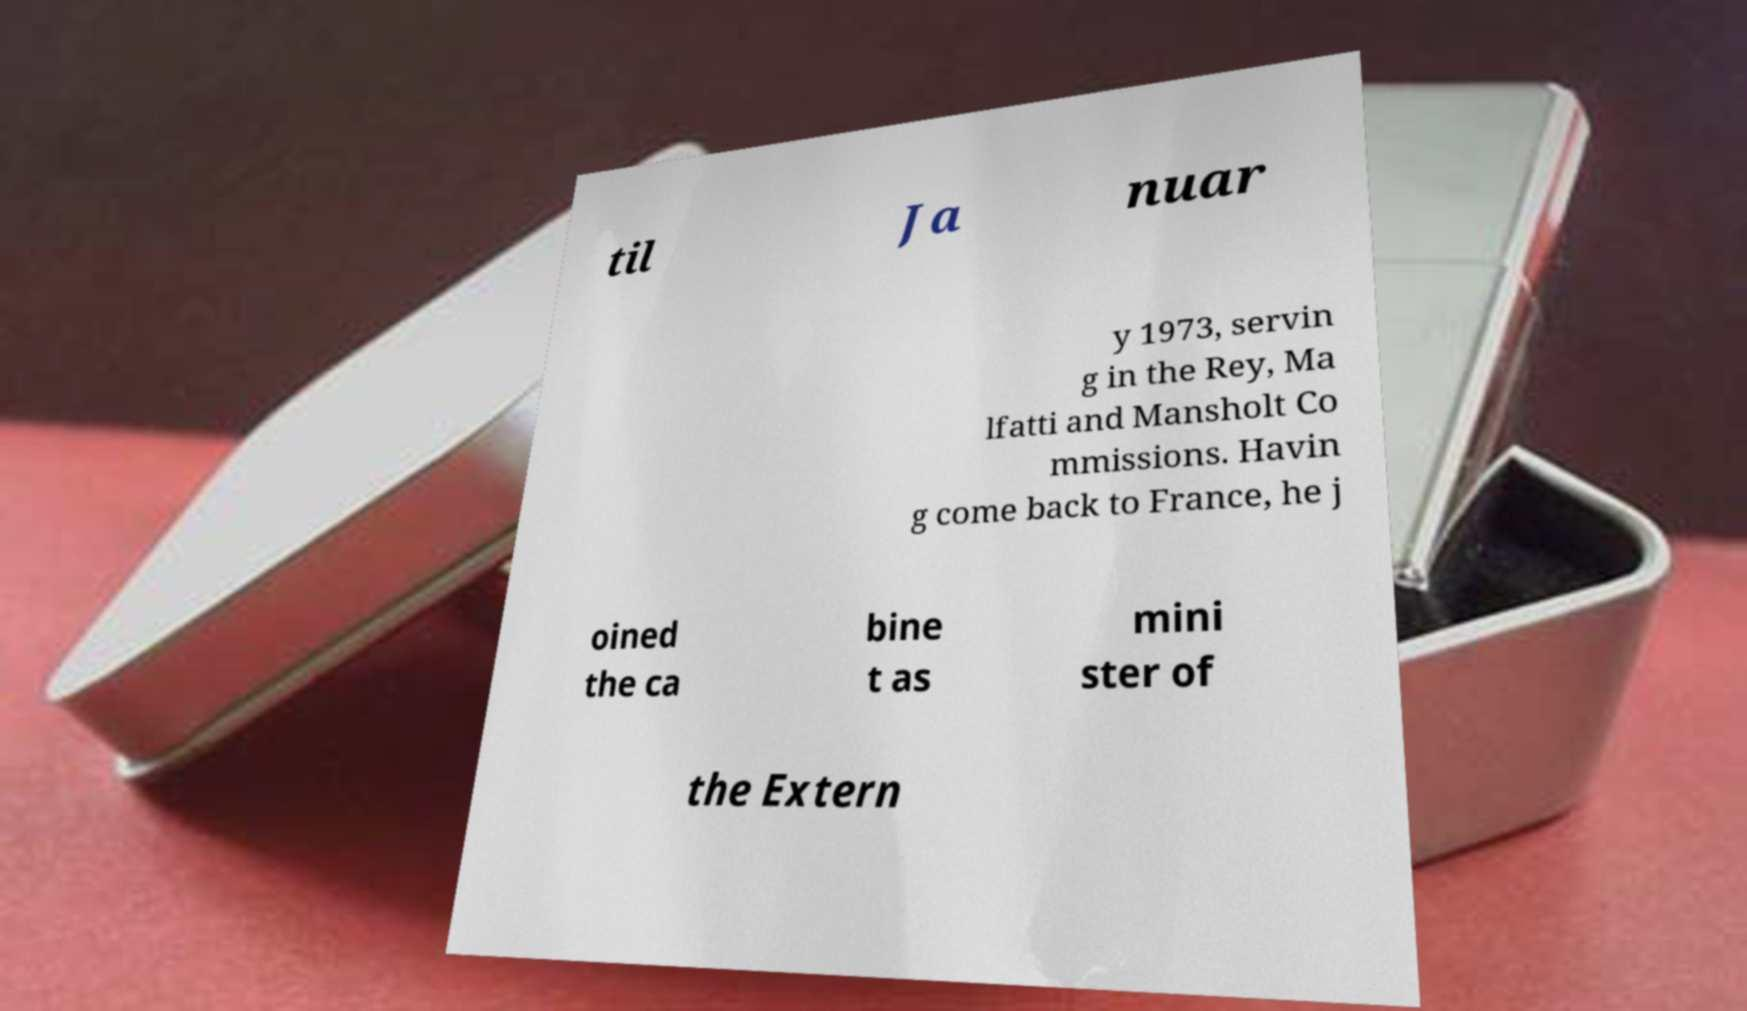There's text embedded in this image that I need extracted. Can you transcribe it verbatim? til Ja nuar y 1973, servin g in the Rey, Ma lfatti and Mansholt Co mmissions. Havin g come back to France, he j oined the ca bine t as mini ster of the Extern 